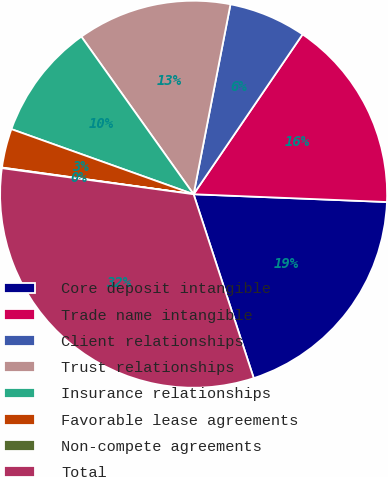Convert chart to OTSL. <chart><loc_0><loc_0><loc_500><loc_500><pie_chart><fcel>Core deposit intangible<fcel>Trade name intangible<fcel>Client relationships<fcel>Trust relationships<fcel>Insurance relationships<fcel>Favorable lease agreements<fcel>Non-compete agreements<fcel>Total<nl><fcel>19.33%<fcel>16.12%<fcel>6.47%<fcel>12.9%<fcel>9.69%<fcel>3.26%<fcel>0.05%<fcel>32.18%<nl></chart> 